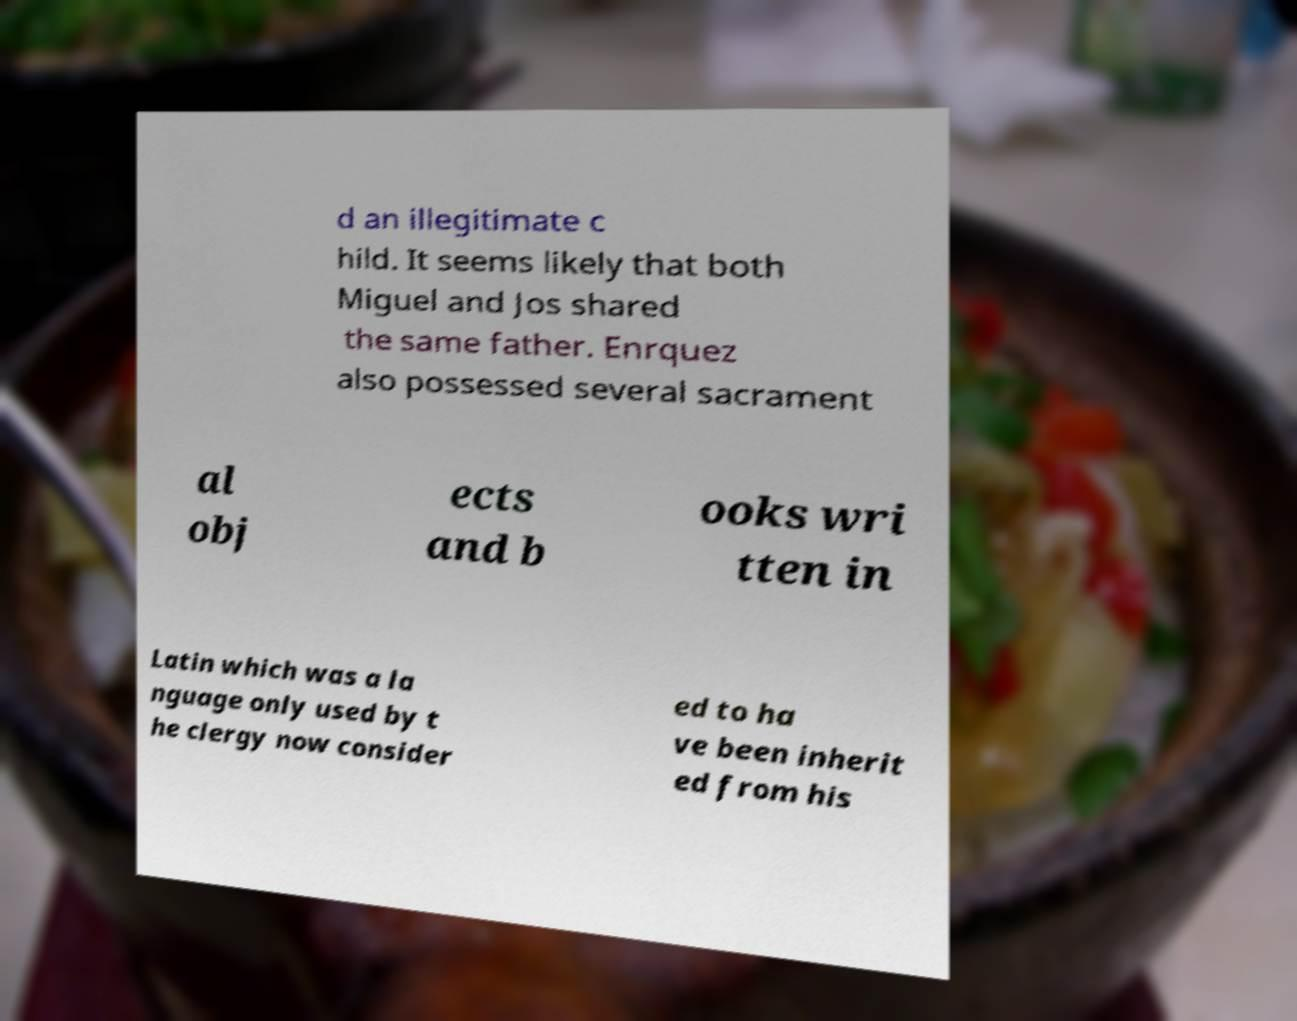What messages or text are displayed in this image? I need them in a readable, typed format. d an illegitimate c hild. It seems likely that both Miguel and Jos shared the same father. Enrquez also possessed several sacrament al obj ects and b ooks wri tten in Latin which was a la nguage only used by t he clergy now consider ed to ha ve been inherit ed from his 